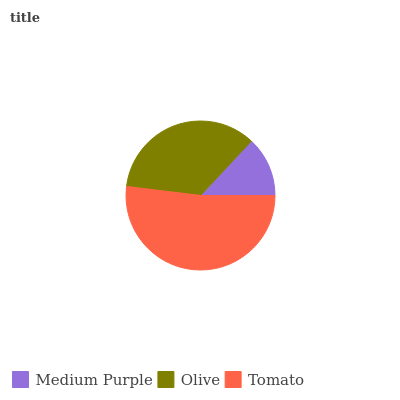Is Medium Purple the minimum?
Answer yes or no. Yes. Is Tomato the maximum?
Answer yes or no. Yes. Is Olive the minimum?
Answer yes or no. No. Is Olive the maximum?
Answer yes or no. No. Is Olive greater than Medium Purple?
Answer yes or no. Yes. Is Medium Purple less than Olive?
Answer yes or no. Yes. Is Medium Purple greater than Olive?
Answer yes or no. No. Is Olive less than Medium Purple?
Answer yes or no. No. Is Olive the high median?
Answer yes or no. Yes. Is Olive the low median?
Answer yes or no. Yes. Is Medium Purple the high median?
Answer yes or no. No. Is Medium Purple the low median?
Answer yes or no. No. 